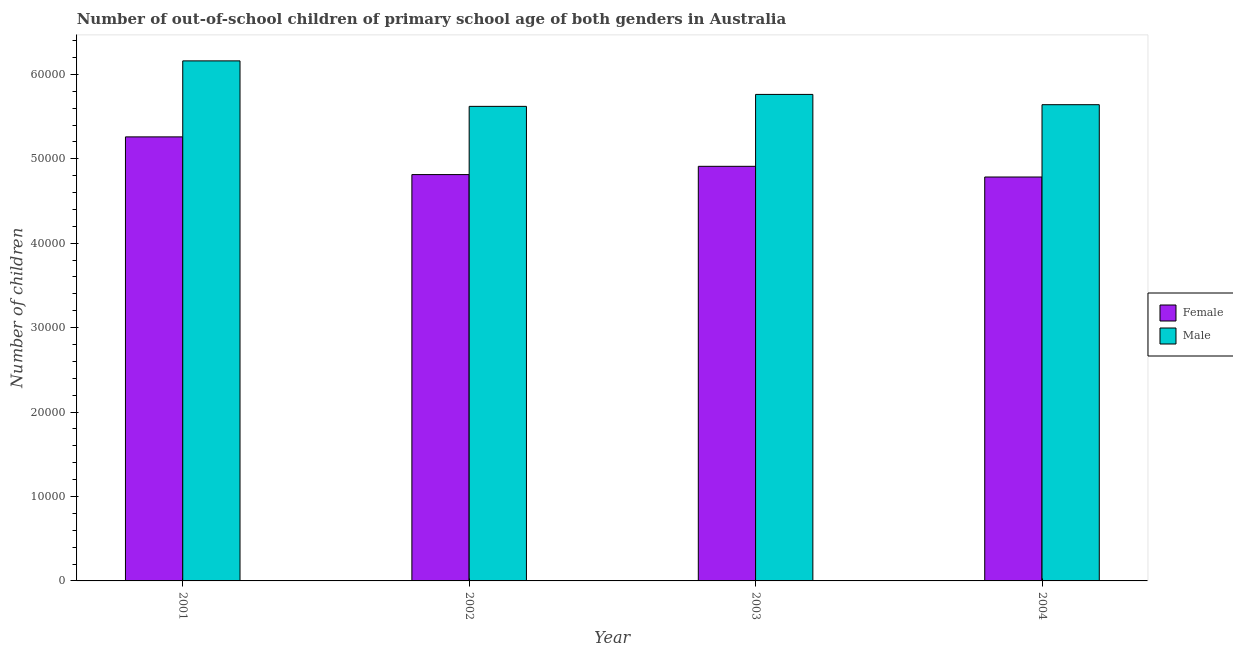How many groups of bars are there?
Give a very brief answer. 4. Are the number of bars per tick equal to the number of legend labels?
Your answer should be very brief. Yes. How many bars are there on the 4th tick from the left?
Your answer should be compact. 2. How many bars are there on the 1st tick from the right?
Your answer should be compact. 2. In how many cases, is the number of bars for a given year not equal to the number of legend labels?
Your answer should be compact. 0. What is the number of female out-of-school students in 2004?
Your response must be concise. 4.78e+04. Across all years, what is the maximum number of male out-of-school students?
Provide a short and direct response. 6.16e+04. Across all years, what is the minimum number of female out-of-school students?
Offer a terse response. 4.78e+04. In which year was the number of female out-of-school students minimum?
Make the answer very short. 2004. What is the total number of male out-of-school students in the graph?
Provide a succinct answer. 2.32e+05. What is the difference between the number of male out-of-school students in 2002 and that in 2004?
Your answer should be compact. -198. What is the difference between the number of female out-of-school students in 2001 and the number of male out-of-school students in 2004?
Provide a short and direct response. 4752. What is the average number of male out-of-school students per year?
Your answer should be compact. 5.80e+04. In how many years, is the number of female out-of-school students greater than 42000?
Offer a terse response. 4. What is the ratio of the number of female out-of-school students in 2002 to that in 2004?
Your answer should be compact. 1.01. Is the difference between the number of male out-of-school students in 2001 and 2004 greater than the difference between the number of female out-of-school students in 2001 and 2004?
Provide a succinct answer. No. What is the difference between the highest and the second highest number of female out-of-school students?
Offer a very short reply. 3486. What is the difference between the highest and the lowest number of female out-of-school students?
Offer a very short reply. 4752. In how many years, is the number of female out-of-school students greater than the average number of female out-of-school students taken over all years?
Provide a short and direct response. 1. What does the 1st bar from the right in 2002 represents?
Offer a terse response. Male. Are all the bars in the graph horizontal?
Your answer should be compact. No. How many years are there in the graph?
Your answer should be compact. 4. Are the values on the major ticks of Y-axis written in scientific E-notation?
Keep it short and to the point. No. Does the graph contain any zero values?
Offer a very short reply. No. Where does the legend appear in the graph?
Your response must be concise. Center right. How are the legend labels stacked?
Offer a terse response. Vertical. What is the title of the graph?
Your response must be concise. Number of out-of-school children of primary school age of both genders in Australia. Does "Current US$" appear as one of the legend labels in the graph?
Offer a terse response. No. What is the label or title of the Y-axis?
Your answer should be very brief. Number of children. What is the Number of children of Female in 2001?
Ensure brevity in your answer.  5.26e+04. What is the Number of children of Male in 2001?
Offer a terse response. 6.16e+04. What is the Number of children of Female in 2002?
Keep it short and to the point. 4.81e+04. What is the Number of children of Male in 2002?
Provide a short and direct response. 5.62e+04. What is the Number of children in Female in 2003?
Offer a terse response. 4.91e+04. What is the Number of children in Male in 2003?
Ensure brevity in your answer.  5.76e+04. What is the Number of children of Female in 2004?
Provide a short and direct response. 4.78e+04. What is the Number of children of Male in 2004?
Your answer should be very brief. 5.64e+04. Across all years, what is the maximum Number of children in Female?
Offer a terse response. 5.26e+04. Across all years, what is the maximum Number of children of Male?
Ensure brevity in your answer.  6.16e+04. Across all years, what is the minimum Number of children in Female?
Make the answer very short. 4.78e+04. Across all years, what is the minimum Number of children of Male?
Give a very brief answer. 5.62e+04. What is the total Number of children of Female in the graph?
Your answer should be compact. 1.98e+05. What is the total Number of children in Male in the graph?
Offer a terse response. 2.32e+05. What is the difference between the Number of children of Female in 2001 and that in 2002?
Provide a short and direct response. 4466. What is the difference between the Number of children in Male in 2001 and that in 2002?
Make the answer very short. 5388. What is the difference between the Number of children of Female in 2001 and that in 2003?
Provide a succinct answer. 3486. What is the difference between the Number of children of Male in 2001 and that in 2003?
Ensure brevity in your answer.  3973. What is the difference between the Number of children in Female in 2001 and that in 2004?
Ensure brevity in your answer.  4752. What is the difference between the Number of children of Male in 2001 and that in 2004?
Provide a succinct answer. 5190. What is the difference between the Number of children of Female in 2002 and that in 2003?
Provide a succinct answer. -980. What is the difference between the Number of children in Male in 2002 and that in 2003?
Make the answer very short. -1415. What is the difference between the Number of children of Female in 2002 and that in 2004?
Ensure brevity in your answer.  286. What is the difference between the Number of children of Male in 2002 and that in 2004?
Keep it short and to the point. -198. What is the difference between the Number of children in Female in 2003 and that in 2004?
Ensure brevity in your answer.  1266. What is the difference between the Number of children of Male in 2003 and that in 2004?
Give a very brief answer. 1217. What is the difference between the Number of children in Female in 2001 and the Number of children in Male in 2002?
Offer a very short reply. -3615. What is the difference between the Number of children in Female in 2001 and the Number of children in Male in 2003?
Give a very brief answer. -5030. What is the difference between the Number of children of Female in 2001 and the Number of children of Male in 2004?
Your response must be concise. -3813. What is the difference between the Number of children in Female in 2002 and the Number of children in Male in 2003?
Keep it short and to the point. -9496. What is the difference between the Number of children of Female in 2002 and the Number of children of Male in 2004?
Make the answer very short. -8279. What is the difference between the Number of children in Female in 2003 and the Number of children in Male in 2004?
Keep it short and to the point. -7299. What is the average Number of children in Female per year?
Your response must be concise. 4.94e+04. What is the average Number of children of Male per year?
Your response must be concise. 5.80e+04. In the year 2001, what is the difference between the Number of children of Female and Number of children of Male?
Give a very brief answer. -9003. In the year 2002, what is the difference between the Number of children in Female and Number of children in Male?
Offer a terse response. -8081. In the year 2003, what is the difference between the Number of children in Female and Number of children in Male?
Ensure brevity in your answer.  -8516. In the year 2004, what is the difference between the Number of children of Female and Number of children of Male?
Your answer should be very brief. -8565. What is the ratio of the Number of children of Female in 2001 to that in 2002?
Make the answer very short. 1.09. What is the ratio of the Number of children in Male in 2001 to that in 2002?
Make the answer very short. 1.1. What is the ratio of the Number of children of Female in 2001 to that in 2003?
Your answer should be compact. 1.07. What is the ratio of the Number of children of Male in 2001 to that in 2003?
Your response must be concise. 1.07. What is the ratio of the Number of children of Female in 2001 to that in 2004?
Make the answer very short. 1.1. What is the ratio of the Number of children of Male in 2001 to that in 2004?
Offer a terse response. 1.09. What is the ratio of the Number of children of Female in 2002 to that in 2003?
Ensure brevity in your answer.  0.98. What is the ratio of the Number of children of Male in 2002 to that in 2003?
Offer a very short reply. 0.98. What is the ratio of the Number of children of Female in 2002 to that in 2004?
Keep it short and to the point. 1.01. What is the ratio of the Number of children of Female in 2003 to that in 2004?
Your response must be concise. 1.03. What is the ratio of the Number of children of Male in 2003 to that in 2004?
Keep it short and to the point. 1.02. What is the difference between the highest and the second highest Number of children of Female?
Offer a terse response. 3486. What is the difference between the highest and the second highest Number of children of Male?
Give a very brief answer. 3973. What is the difference between the highest and the lowest Number of children of Female?
Your answer should be compact. 4752. What is the difference between the highest and the lowest Number of children of Male?
Keep it short and to the point. 5388. 